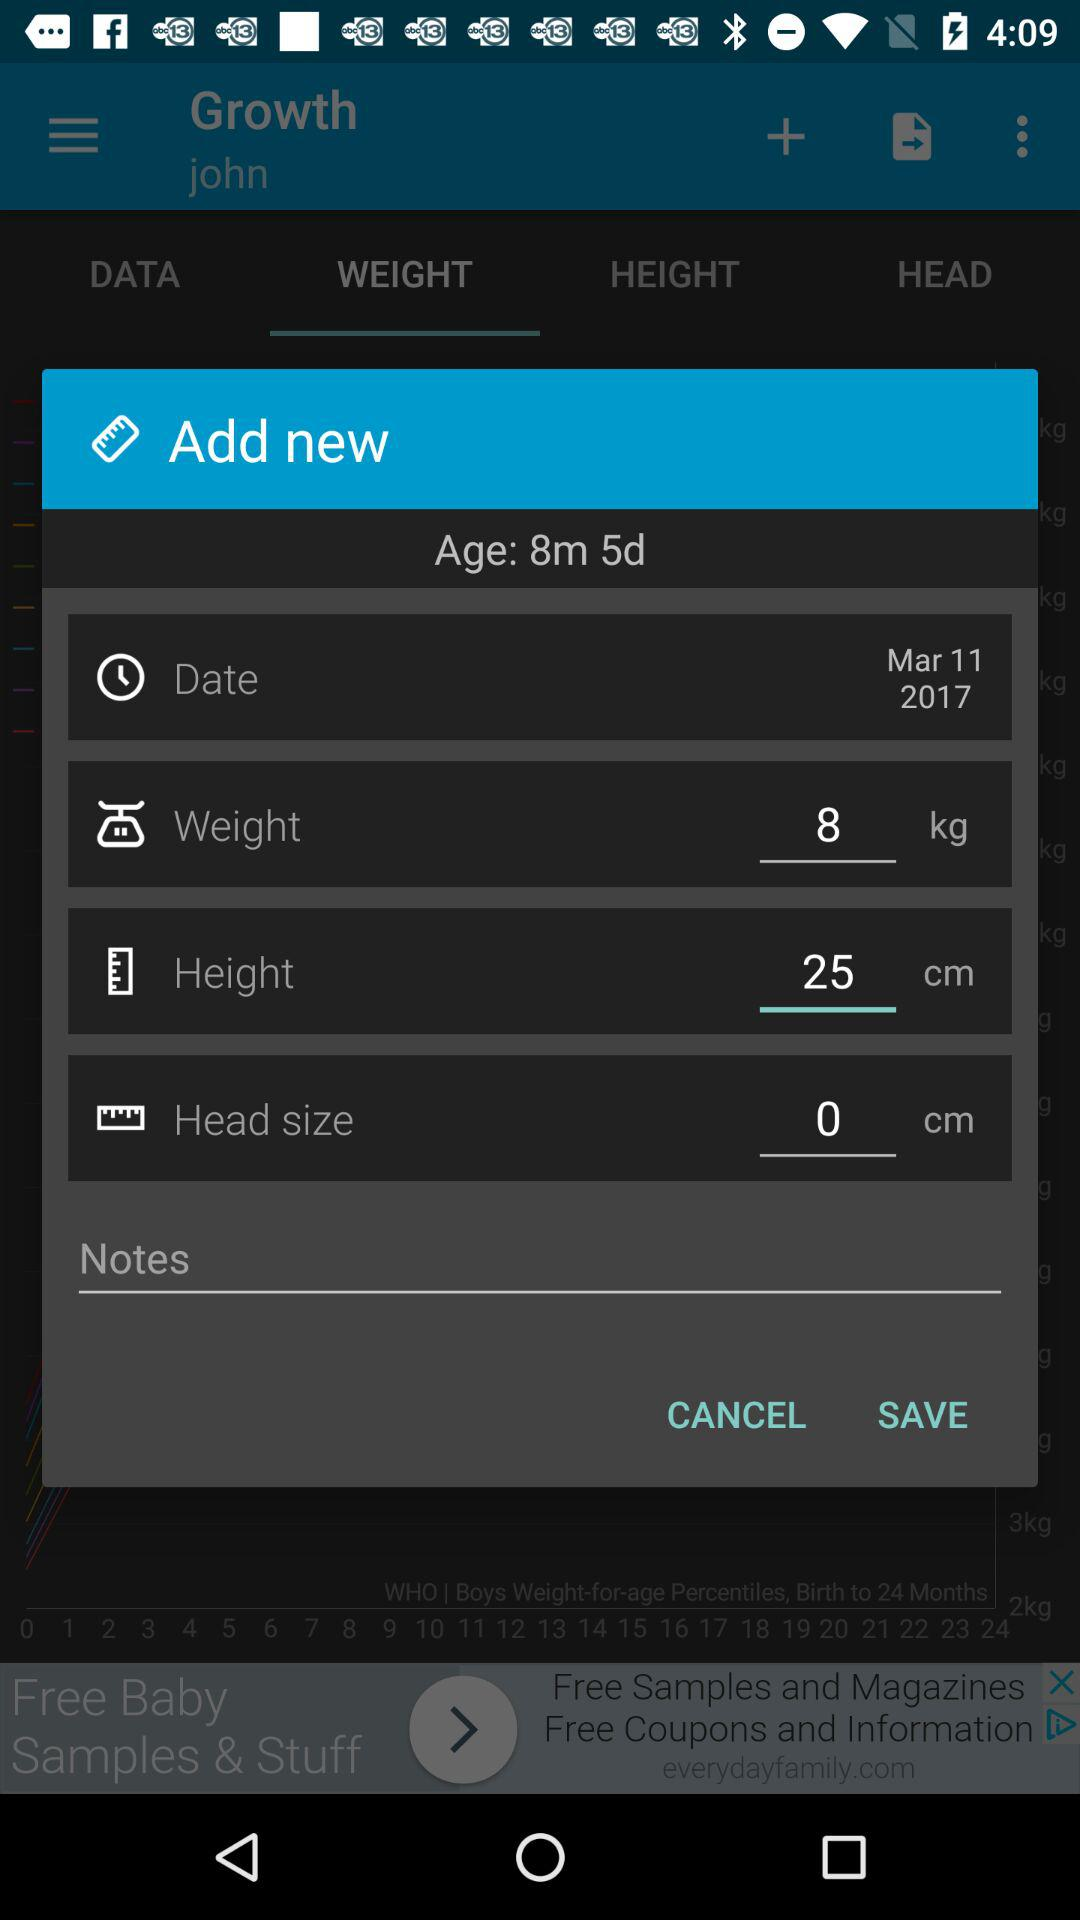What is the significance of tracking a baby's growth metrics like weight, height, and head size? Tracking a baby's growth metrics including weight, height, and head circumference is crucial for assessing their development. It helps in detecting any potential health issues early on. Monitoring these metrics against standardized growth charts can inform if the baby is growing at a healthy rate compared to other babies of the same age and sex. 